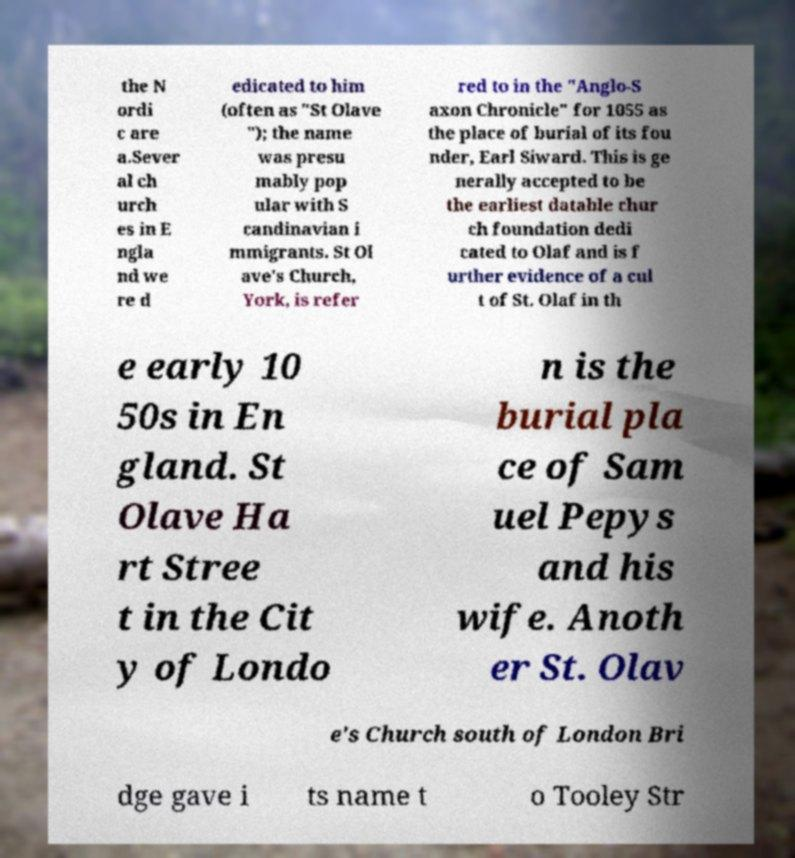Can you read and provide the text displayed in the image?This photo seems to have some interesting text. Can you extract and type it out for me? the N ordi c are a.Sever al ch urch es in E ngla nd we re d edicated to him (often as "St Olave "); the name was presu mably pop ular with S candinavian i mmigrants. St Ol ave's Church, York, is refer red to in the "Anglo-S axon Chronicle" for 1055 as the place of burial of its fou nder, Earl Siward. This is ge nerally accepted to be the earliest datable chur ch foundation dedi cated to Olaf and is f urther evidence of a cul t of St. Olaf in th e early 10 50s in En gland. St Olave Ha rt Stree t in the Cit y of Londo n is the burial pla ce of Sam uel Pepys and his wife. Anoth er St. Olav e's Church south of London Bri dge gave i ts name t o Tooley Str 